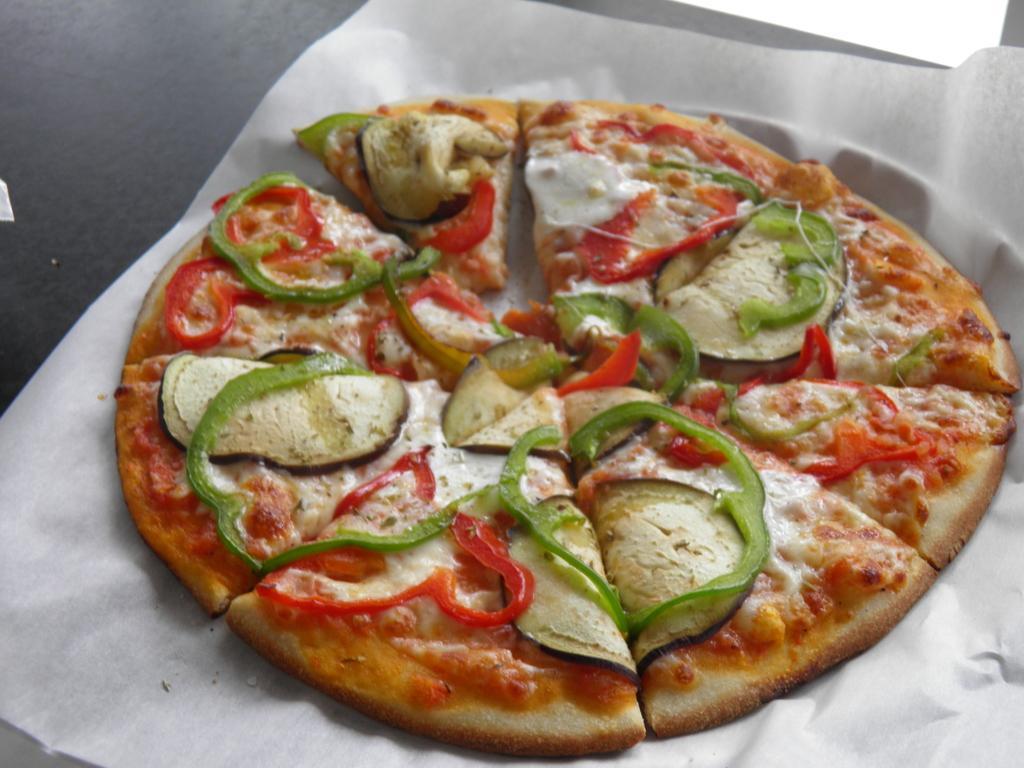Describe this image in one or two sentences. In this image, we can see pizza which is placed on the table. 